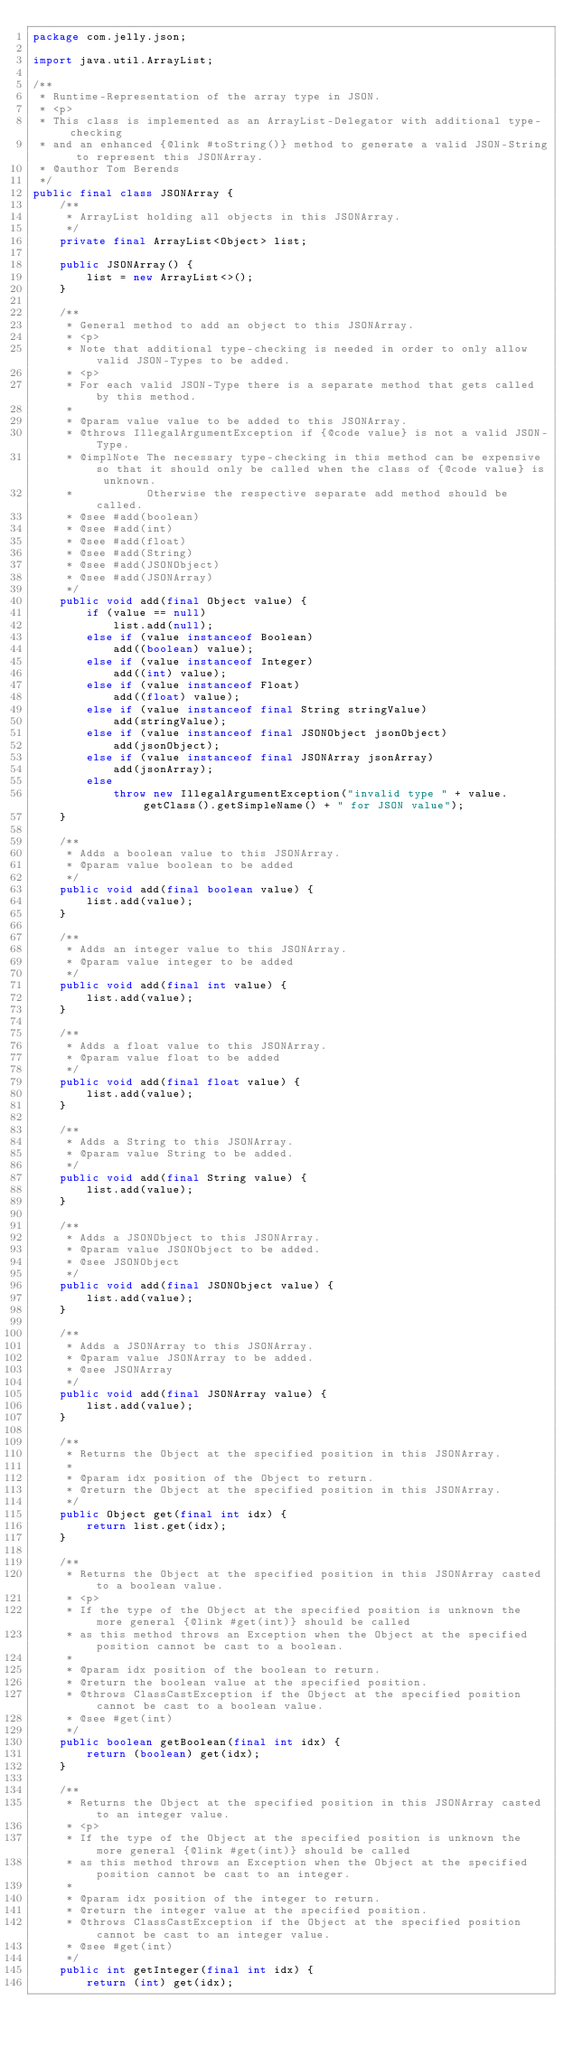Convert code to text. <code><loc_0><loc_0><loc_500><loc_500><_Java_>package com.jelly.json;

import java.util.ArrayList;

/**
 * Runtime-Representation of the array type in JSON.
 * <p>
 * This class is implemented as an ArrayList-Delegator with additional type-checking
 * and an enhanced {@link #toString()} method to generate a valid JSON-String to represent this JSONArray.
 * @author Tom Berends
 */
public final class JSONArray {
    /**
     * ArrayList holding all objects in this JSONArray.
     */
    private final ArrayList<Object> list;

    public JSONArray() {
        list = new ArrayList<>();
    }

    /**
     * General method to add an object to this JSONArray.
     * <p>
     * Note that additional type-checking is needed in order to only allow valid JSON-Types to be added.
     * <p>
     * For each valid JSON-Type there is a separate method that gets called by this method.
     *
     * @param value value to be added to this JSONArray.
     * @throws IllegalArgumentException if {@code value} is not a valid JSON-Type.
     * @implNote The necessary type-checking in this method can be expensive so that it should only be called when the class of {@code value} is unknown.
     *           Otherwise the respective separate add method should be called.
     * @see #add(boolean)
     * @see #add(int)
     * @see #add(float)
     * @see #add(String)
     * @see #add(JSONObject)
     * @see #add(JSONArray)
     */
    public void add(final Object value) {
        if (value == null)
            list.add(null);
        else if (value instanceof Boolean)
            add((boolean) value);
        else if (value instanceof Integer)
            add((int) value);
        else if (value instanceof Float)
            add((float) value);
        else if (value instanceof final String stringValue)
            add(stringValue);
        else if (value instanceof final JSONObject jsonObject)
            add(jsonObject);
        else if (value instanceof final JSONArray jsonArray)
            add(jsonArray);
        else
            throw new IllegalArgumentException("invalid type " + value.getClass().getSimpleName() + " for JSON value");
    }

    /**
     * Adds a boolean value to this JSONArray.
     * @param value boolean to be added
     */
    public void add(final boolean value) {
        list.add(value);
    }

    /**
     * Adds an integer value to this JSONArray.
     * @param value integer to be added
     */
    public void add(final int value) {
        list.add(value);
    }

    /**
     * Adds a float value to this JSONArray.
     * @param value float to be added
     */
    public void add(final float value) {
        list.add(value);
    }

    /**
     * Adds a String to this JSONArray.
     * @param value String to be added.
     */
    public void add(final String value) {
        list.add(value);
    }

    /**
     * Adds a JSONObject to this JSONArray.
     * @param value JSONObject to be added.
     * @see JSONObject
     */
    public void add(final JSONObject value) {
        list.add(value);
    }

    /**
     * Adds a JSONArray to this JSONArray.
     * @param value JSONArray to be added.
     * @see JSONArray
     */
    public void add(final JSONArray value) {
        list.add(value);
    }

    /**
     * Returns the Object at the specified position in this JSONArray.
     *
     * @param idx position of the Object to return.
     * @return the Object at the specified position in this JSONArray.
     */
    public Object get(final int idx) {
        return list.get(idx);
    }

    /**
     * Returns the Object at the specified position in this JSONArray casted to a boolean value.
     * <p>
     * If the type of the Object at the specified position is unknown the more general {@link #get(int)} should be called
     * as this method throws an Exception when the Object at the specified position cannot be cast to a boolean.      
     * 
     * @param idx position of the boolean to return.
     * @return the boolean value at the specified position.
     * @throws ClassCastException if the Object at the specified position cannot be cast to a boolean value.
     * @see #get(int)
     */
    public boolean getBoolean(final int idx) {
        return (boolean) get(idx);
    }

    /**
     * Returns the Object at the specified position in this JSONArray casted to an integer value.
     * <p>
     * If the type of the Object at the specified position is unknown the more general {@link #get(int)} should be called
     * as this method throws an Exception when the Object at the specified position cannot be cast to an integer.      
     *
     * @param idx position of the integer to return.
     * @return the integer value at the specified position.
     * @throws ClassCastException if the Object at the specified position cannot be cast to an integer value.
     * @see #get(int)
     */
    public int getInteger(final int idx) {
        return (int) get(idx);</code> 